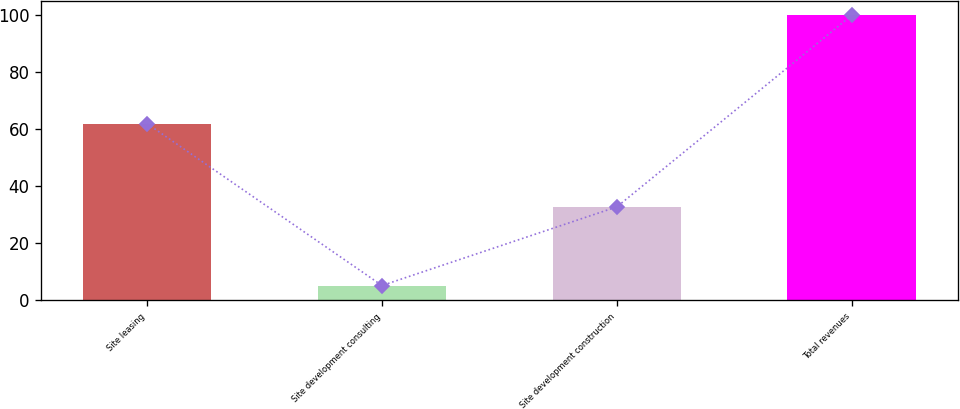Convert chart to OTSL. <chart><loc_0><loc_0><loc_500><loc_500><bar_chart><fcel>Site leasing<fcel>Site development consulting<fcel>Site development construction<fcel>Total revenues<nl><fcel>62<fcel>5.2<fcel>32.8<fcel>100<nl></chart> 